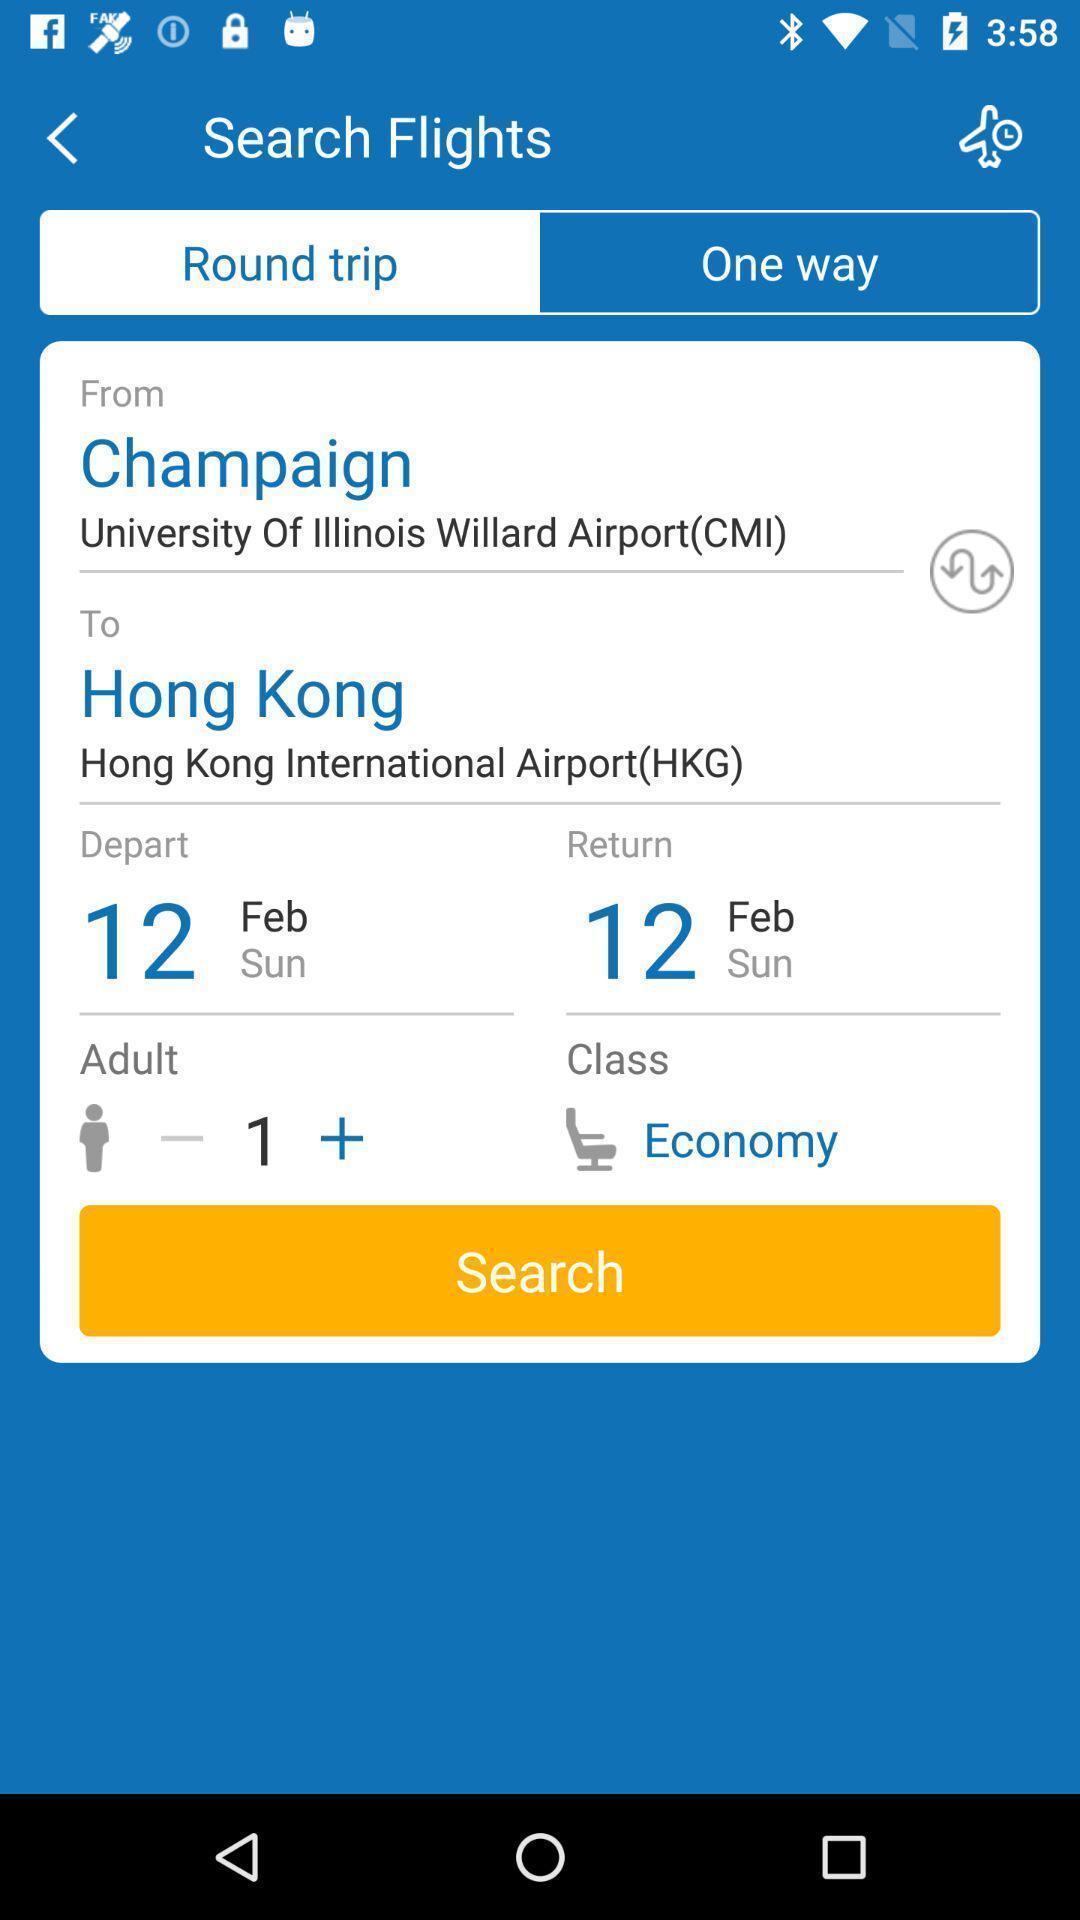Provide a textual representation of this image. Page showing the trip details in travel app. 